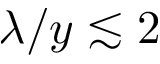<formula> <loc_0><loc_0><loc_500><loc_500>\lambda / y \lesssim 2</formula> 